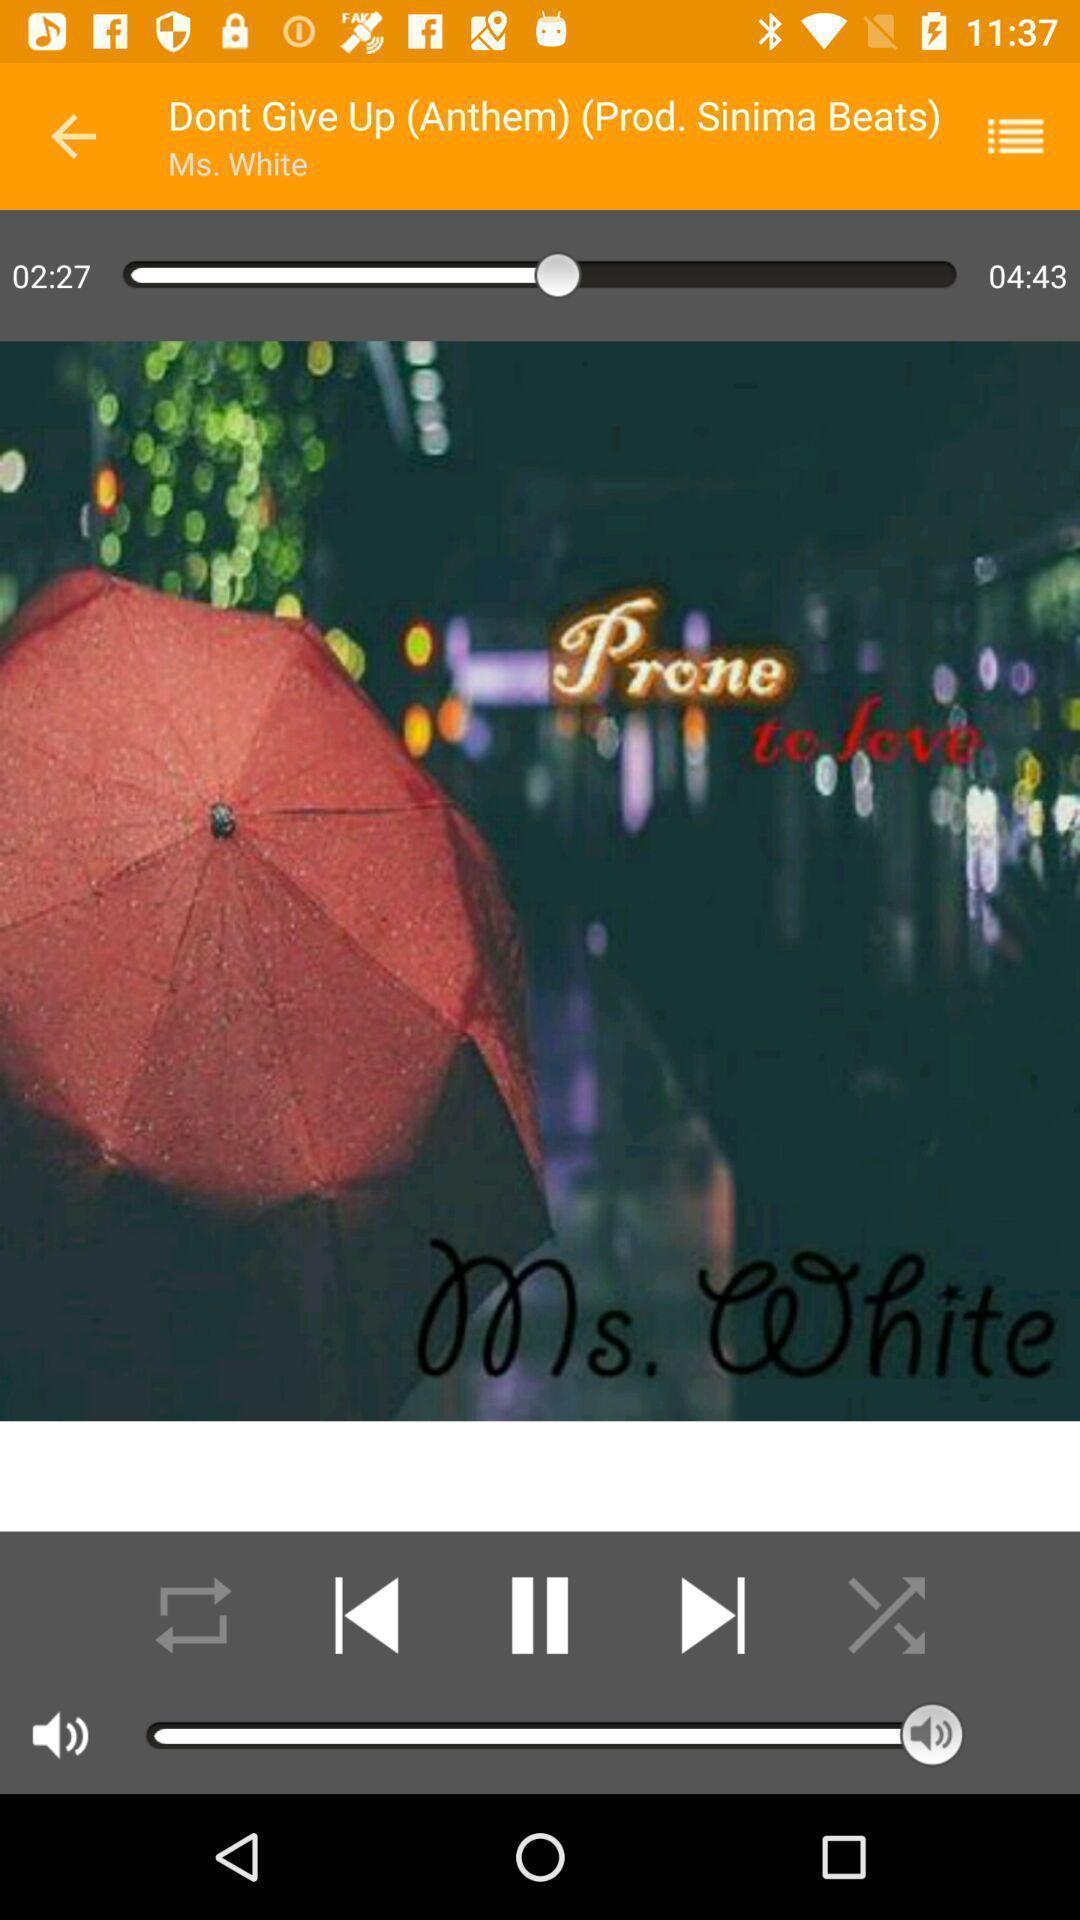Explain the elements present in this screenshot. Screen displaying audio playing with song name. 